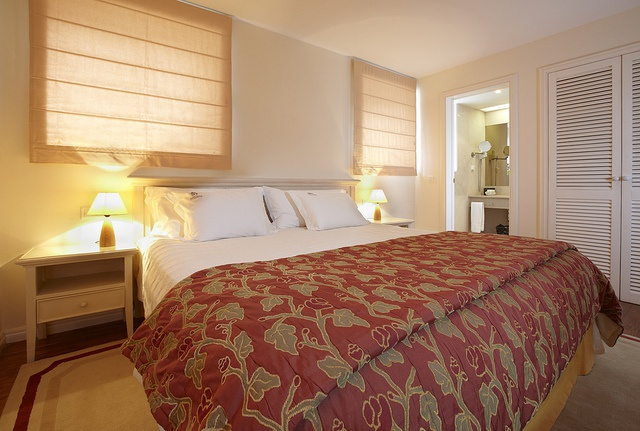Describe the objects in this image and their specific colors. I can see a bed in tan, maroon, gray, and brown tones in this image. 